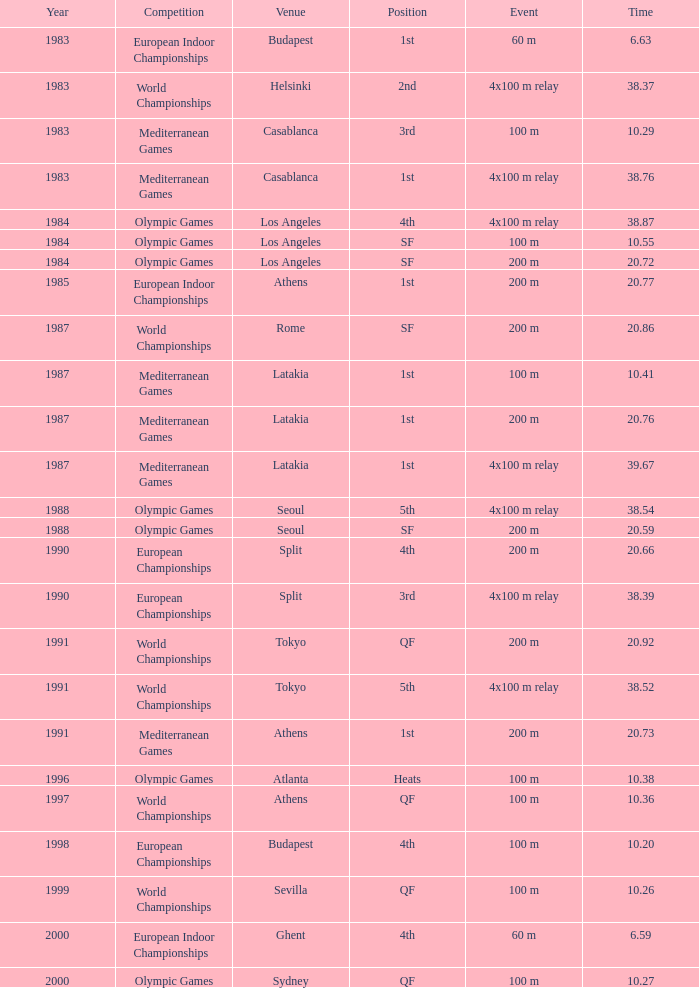Which position possesses a time of 2 4th. 